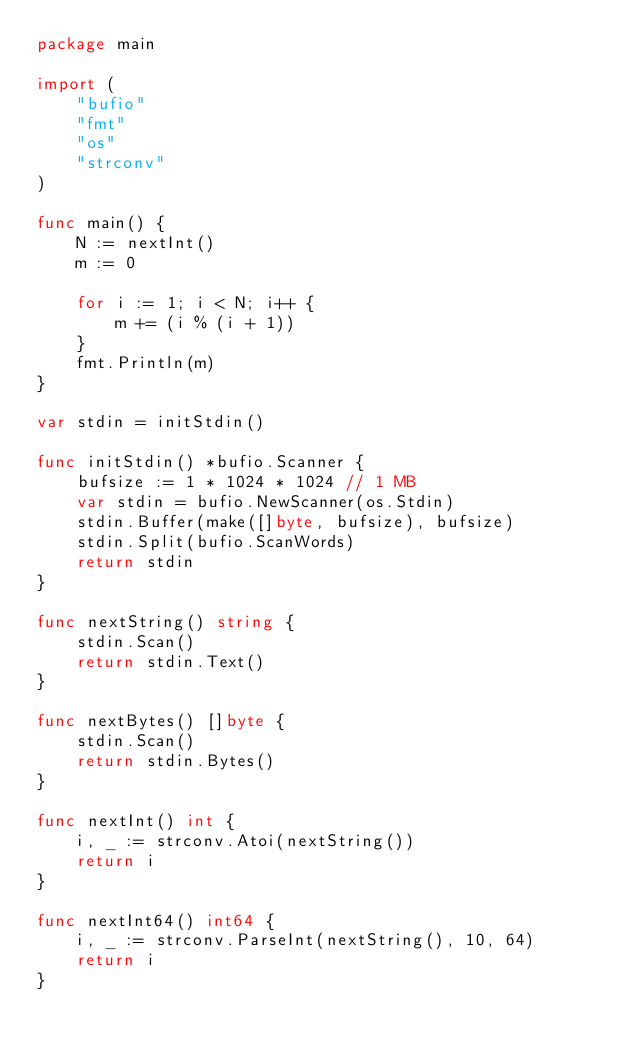Convert code to text. <code><loc_0><loc_0><loc_500><loc_500><_Go_>package main

import (
	"bufio"
	"fmt"
	"os"
	"strconv"
)

func main() {
	N := nextInt()
	m := 0

	for i := 1; i < N; i++ {
		m += (i % (i + 1))
	}
	fmt.Println(m)
}

var stdin = initStdin()

func initStdin() *bufio.Scanner {
	bufsize := 1 * 1024 * 1024 // 1 MB
	var stdin = bufio.NewScanner(os.Stdin)
	stdin.Buffer(make([]byte, bufsize), bufsize)
	stdin.Split(bufio.ScanWords)
	return stdin
}

func nextString() string {
	stdin.Scan()
	return stdin.Text()
}

func nextBytes() []byte {
	stdin.Scan()
	return stdin.Bytes()
}

func nextInt() int {
	i, _ := strconv.Atoi(nextString())
	return i
}

func nextInt64() int64 {
	i, _ := strconv.ParseInt(nextString(), 10, 64)
	return i
}
</code> 